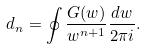<formula> <loc_0><loc_0><loc_500><loc_500>d _ { n } = \oint \frac { G ( w ) } { w ^ { n + 1 } } \frac { d w } { 2 \pi i } .</formula> 